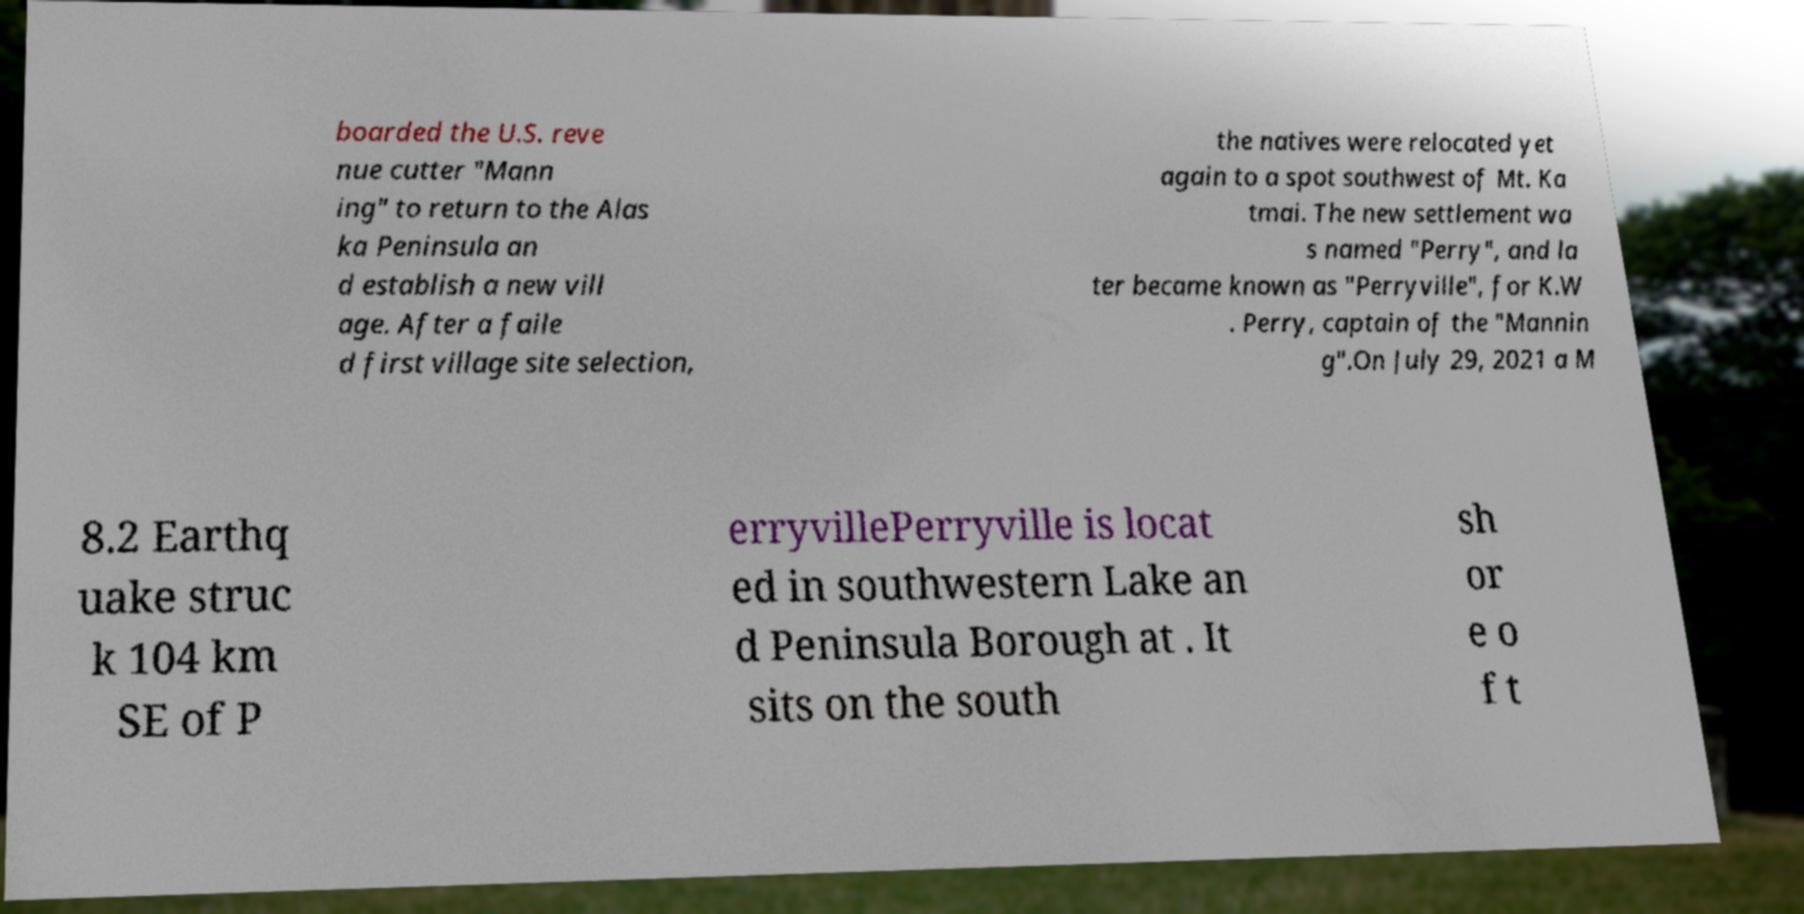Could you extract and type out the text from this image? boarded the U.S. reve nue cutter "Mann ing" to return to the Alas ka Peninsula an d establish a new vill age. After a faile d first village site selection, the natives were relocated yet again to a spot southwest of Mt. Ka tmai. The new settlement wa s named "Perry", and la ter became known as "Perryville", for K.W . Perry, captain of the "Mannin g".On July 29, 2021 a M 8.2 Earthq uake struc k 104 km SE of P erryvillePerryville is locat ed in southwestern Lake an d Peninsula Borough at . It sits on the south sh or e o f t 